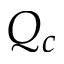<formula> <loc_0><loc_0><loc_500><loc_500>Q _ { c }</formula> 